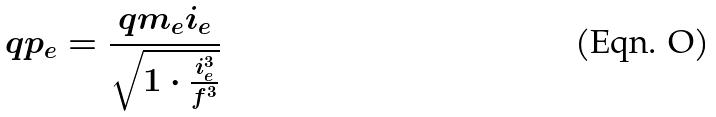<formula> <loc_0><loc_0><loc_500><loc_500>q p _ { e } = \frac { q m _ { e } i _ { e } } { \sqrt { 1 \cdot \frac { i _ { e } ^ { 3 } } { f ^ { 3 } } } }</formula> 